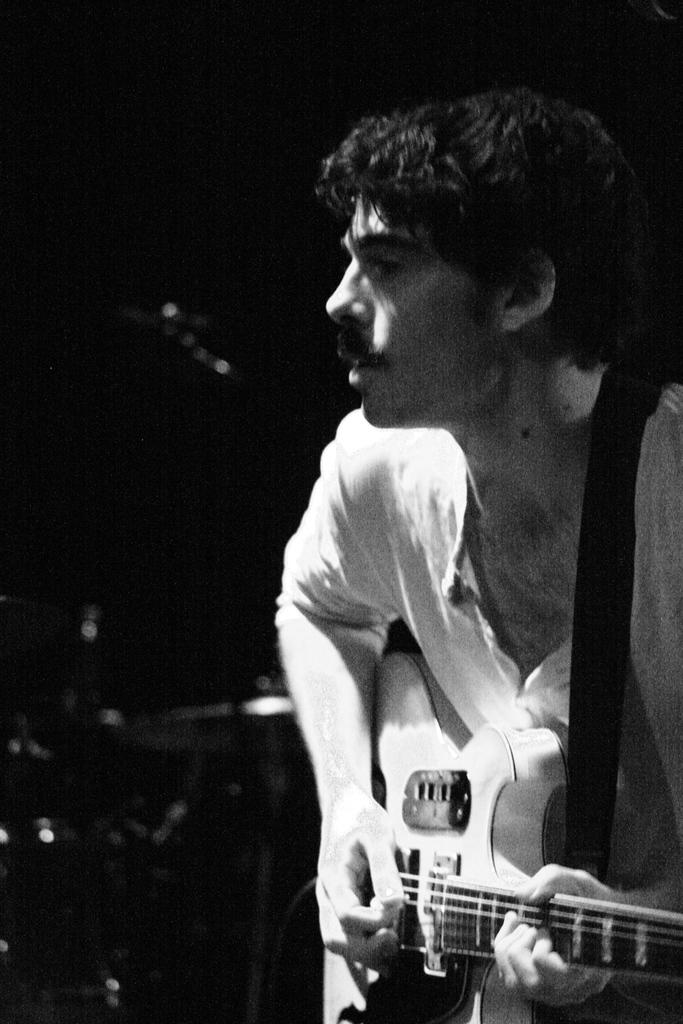What is the main subject of the image? The main subject of the image is a man. What is the man holding in the image? The man is holding a guitar in the image. What is the man doing with the guitar? The man is playing the guitar in the image. What type of cannon is the man using to play the guitar in the image? There is no cannon present in the image; the man is playing a guitar. How does the man's heart rate change while playing the guitar in the image? The image does not provide information about the man's heart rate, so we cannot determine how it changes while playing the guitar. 